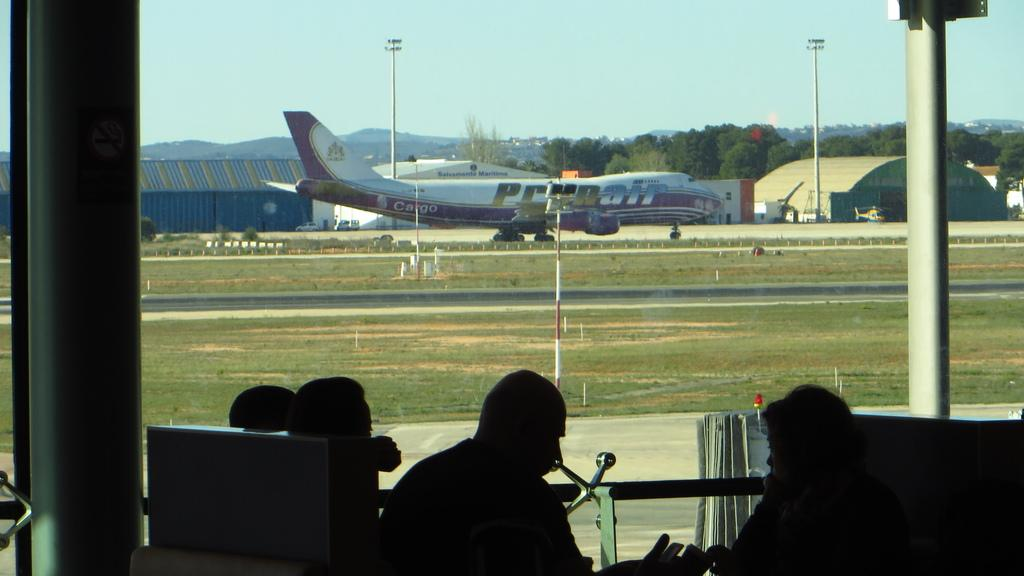<image>
Write a terse but informative summary of the picture. A photo of a plane at an airport labeled cargo. 